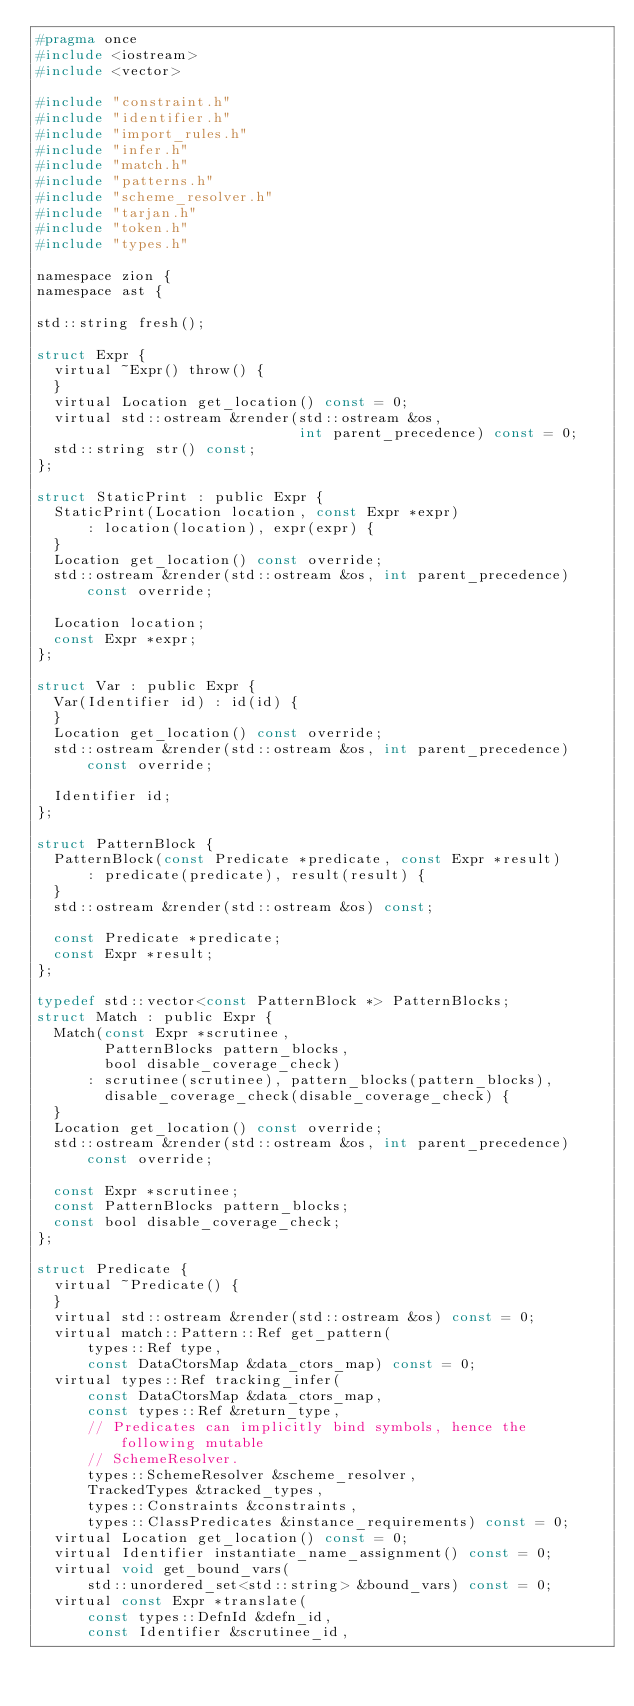<code> <loc_0><loc_0><loc_500><loc_500><_C_>#pragma once
#include <iostream>
#include <vector>

#include "constraint.h"
#include "identifier.h"
#include "import_rules.h"
#include "infer.h"
#include "match.h"
#include "patterns.h"
#include "scheme_resolver.h"
#include "tarjan.h"
#include "token.h"
#include "types.h"

namespace zion {
namespace ast {

std::string fresh();

struct Expr {
  virtual ~Expr() throw() {
  }
  virtual Location get_location() const = 0;
  virtual std::ostream &render(std::ostream &os,
                               int parent_precedence) const = 0;
  std::string str() const;
};

struct StaticPrint : public Expr {
  StaticPrint(Location location, const Expr *expr)
      : location(location), expr(expr) {
  }
  Location get_location() const override;
  std::ostream &render(std::ostream &os, int parent_precedence) const override;

  Location location;
  const Expr *expr;
};

struct Var : public Expr {
  Var(Identifier id) : id(id) {
  }
  Location get_location() const override;
  std::ostream &render(std::ostream &os, int parent_precedence) const override;

  Identifier id;
};

struct PatternBlock {
  PatternBlock(const Predicate *predicate, const Expr *result)
      : predicate(predicate), result(result) {
  }
  std::ostream &render(std::ostream &os) const;

  const Predicate *predicate;
  const Expr *result;
};

typedef std::vector<const PatternBlock *> PatternBlocks;
struct Match : public Expr {
  Match(const Expr *scrutinee,
        PatternBlocks pattern_blocks,
        bool disable_coverage_check)
      : scrutinee(scrutinee), pattern_blocks(pattern_blocks),
        disable_coverage_check(disable_coverage_check) {
  }
  Location get_location() const override;
  std::ostream &render(std::ostream &os, int parent_precedence) const override;

  const Expr *scrutinee;
  const PatternBlocks pattern_blocks;
  const bool disable_coverage_check;
};

struct Predicate {
  virtual ~Predicate() {
  }
  virtual std::ostream &render(std::ostream &os) const = 0;
  virtual match::Pattern::Ref get_pattern(
      types::Ref type,
      const DataCtorsMap &data_ctors_map) const = 0;
  virtual types::Ref tracking_infer(
      const DataCtorsMap &data_ctors_map,
      const types::Ref &return_type,
      // Predicates can implicitly bind symbols, hence the following mutable
      // SchemeResolver.
      types::SchemeResolver &scheme_resolver,
      TrackedTypes &tracked_types,
      types::Constraints &constraints,
      types::ClassPredicates &instance_requirements) const = 0;
  virtual Location get_location() const = 0;
  virtual Identifier instantiate_name_assignment() const = 0;
  virtual void get_bound_vars(
      std::unordered_set<std::string> &bound_vars) const = 0;
  virtual const Expr *translate(
      const types::DefnId &defn_id,
      const Identifier &scrutinee_id,</code> 